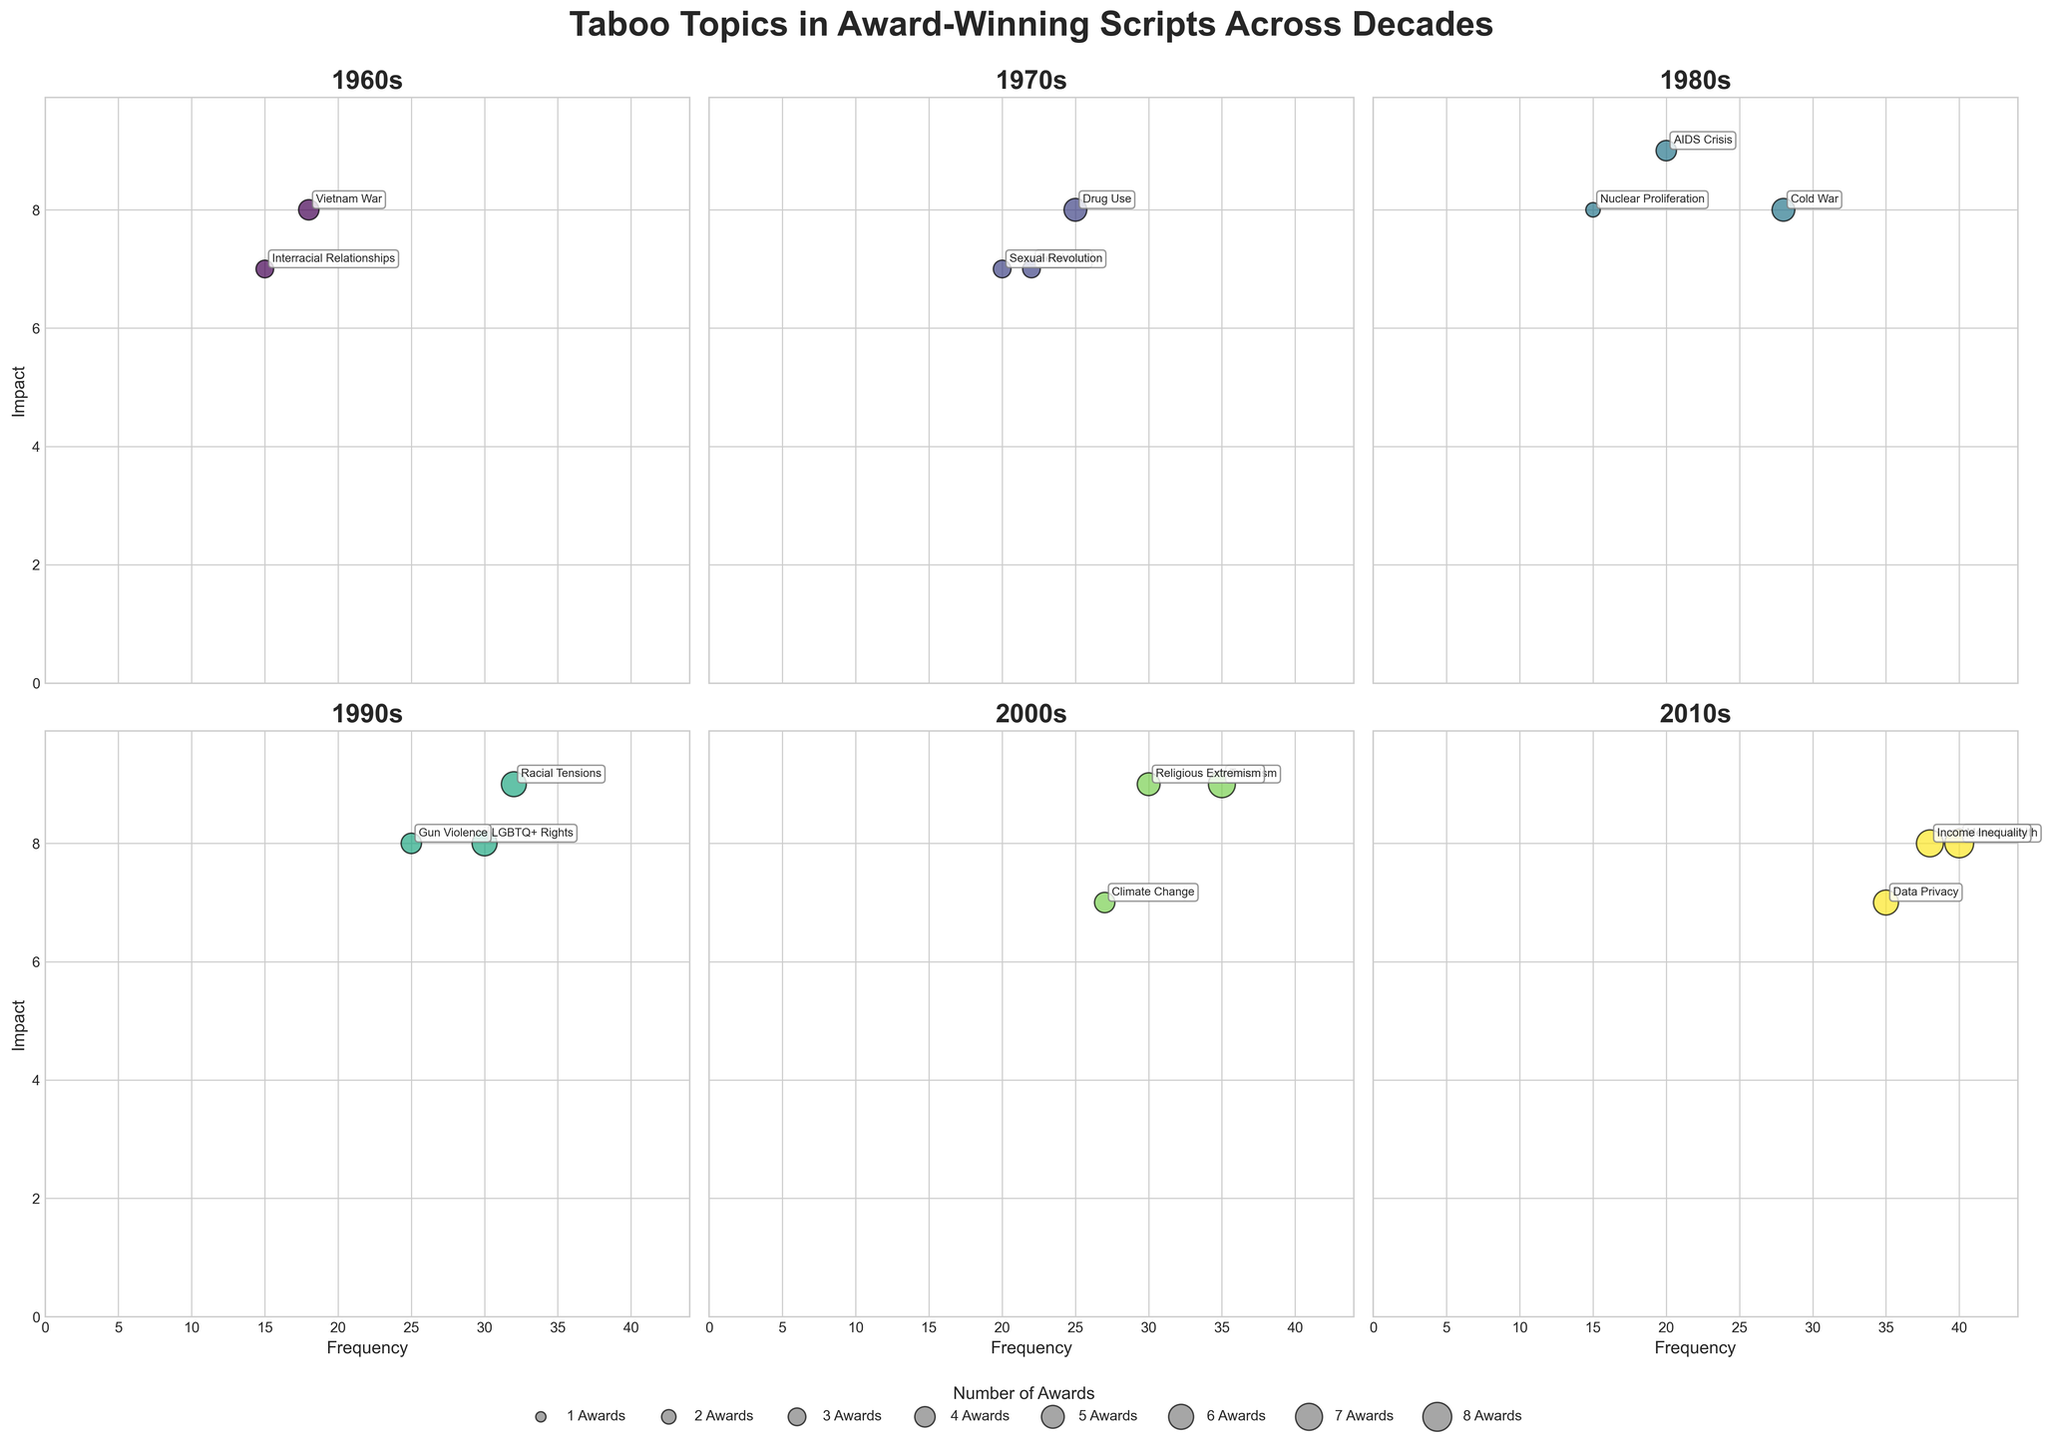How many topics are depicted in the 2000s subplot? Look at the subplot titled "2000s" and count the number of bubbles. Each bubble represents a topic.
Answer: 4 Which decade has the highest frequency of discussions on Mental Health? Check the subplot for each decade and identify which one has a bubble labeled "Mental Health" with the highest x-axis value (Frequency).
Answer: 2010s Which topic in the 1990s has the highest impact? Look at the 1990s subplot and identify the bubble with the highest y-axis position (Impact). Refer to the topic label next to this bubble.
Answer: Racial Tensions Comparing the 1980s and 2000s, which decade has a higher average impact of topics? Calculate the average impact for each decade. For 1980s: (9 + 8 + 8 + 8) / 4 = 8.25. For 2000s: (9 + 9 + 7 + 9) / 4 = 8.5. Compare these values.
Answer: 2000s How are award counts visually represented in the scatter plot? Observe the bubble sizes and legend under the figure, which explain that larger bubbles correspond to a higher number of awards.
Answer: Bubble sizes Which decade has the most impactful topic related to LGBTQ+ Rights and what is its impact value? Look at the subplot for each decade that has "LGBTQ+ Rights" labeled and identify its position on the y-axis.
Answer: 1990s, 8 Between the 1970s and 2010s, which decade contains a topic that combines high frequency with high impact the most? Compare both decades by looking for bubbles positioned high on both the x-axis (Frequency) and y-axis (Impact). The Income Inequality bubble in the 2010s stands out for its high values.
Answer: 2010s What is the total number of topics discussed in the 1970s? Count the number of bubbles in the "1970s" subplot.
Answer: 4 